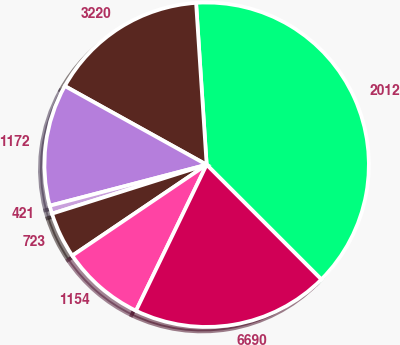Convert chart. <chart><loc_0><loc_0><loc_500><loc_500><pie_chart><fcel>2012<fcel>3220<fcel>1172<fcel>421<fcel>723<fcel>1154<fcel>6690<nl><fcel>38.54%<fcel>15.9%<fcel>12.13%<fcel>0.81%<fcel>4.59%<fcel>8.36%<fcel>19.67%<nl></chart> 